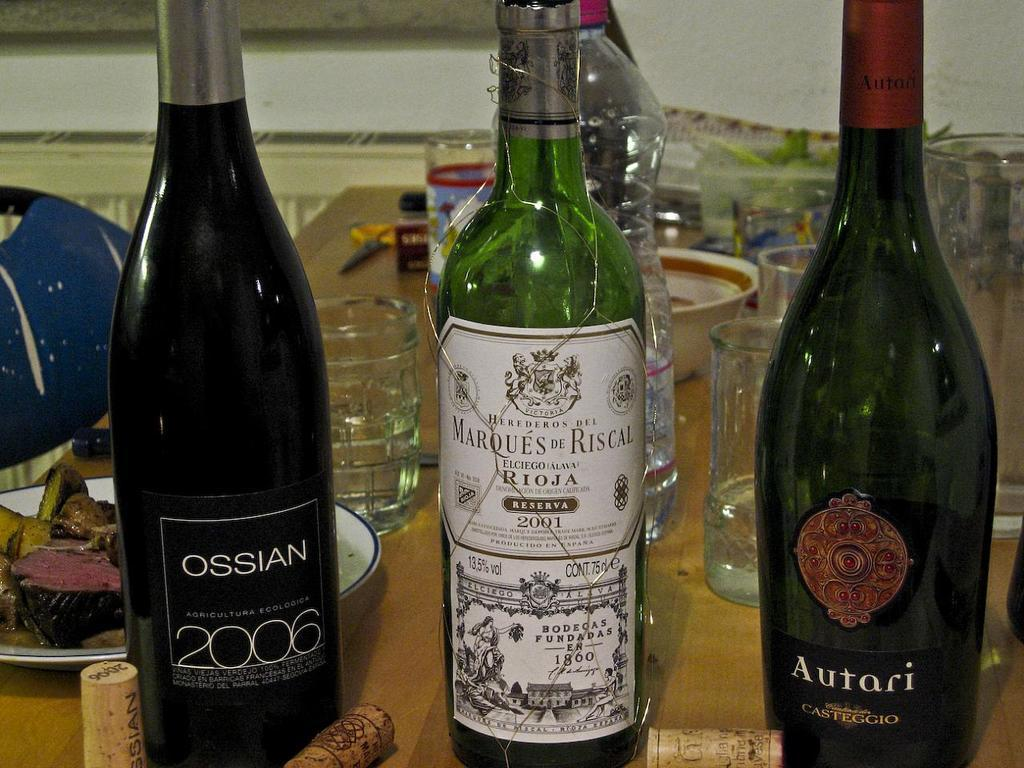<image>
Give a short and clear explanation of the subsequent image. A bottle of Ossian 2006 is next to two other alcohol bottles on a crowded table. 